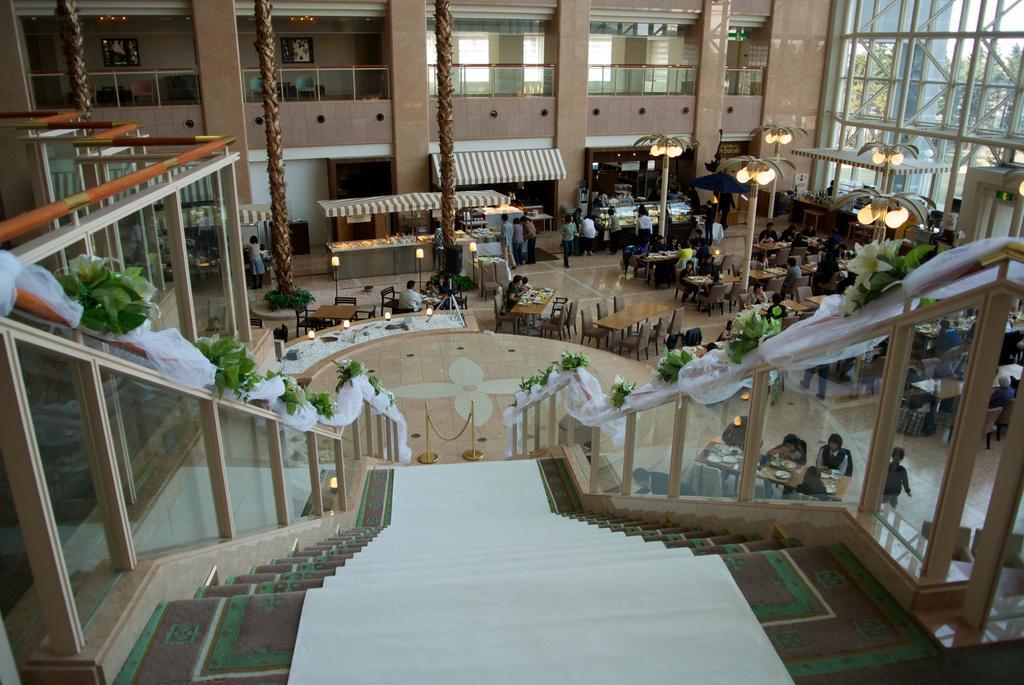How would you summarize this image in a sentence or two? In the center of the image there are staircase. There is a staircase railing. In the background of the image there are stalls, chairs, tables. There are people. There are light poles. To the right side of the image there is a glass with rods. In the background there is a building with pillars and railing. 